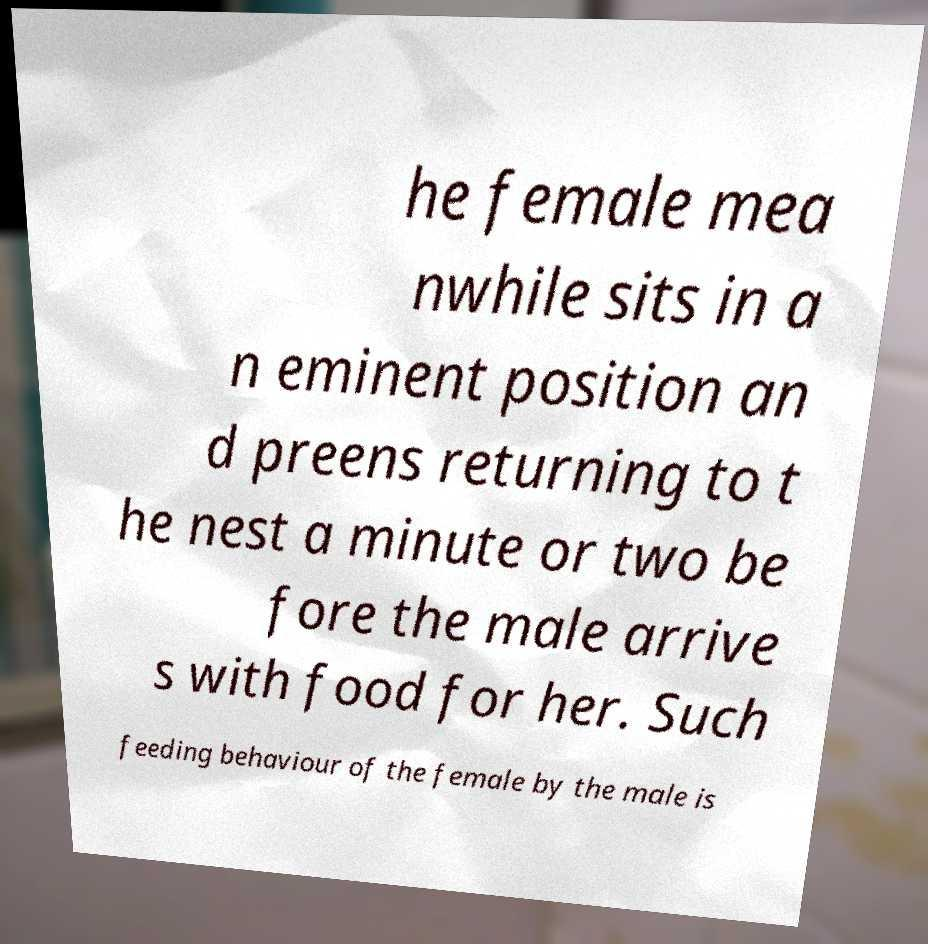Can you accurately transcribe the text from the provided image for me? he female mea nwhile sits in a n eminent position an d preens returning to t he nest a minute or two be fore the male arrive s with food for her. Such feeding behaviour of the female by the male is 